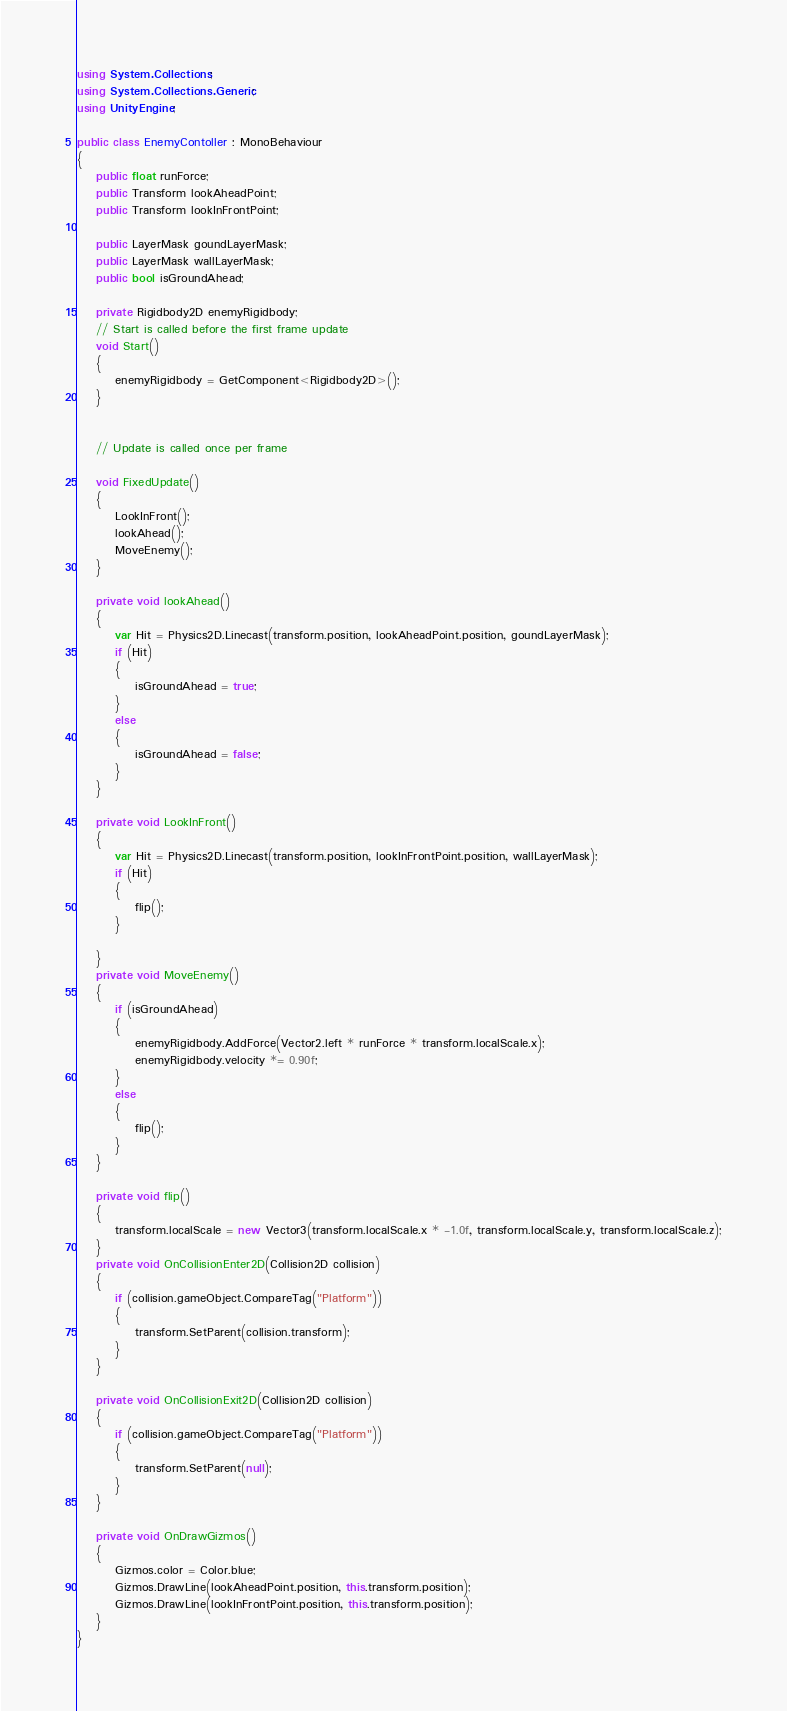Convert code to text. <code><loc_0><loc_0><loc_500><loc_500><_C#_>using System.Collections;
using System.Collections.Generic;
using UnityEngine;

public class EnemyContoller : MonoBehaviour
{
    public float runForce;
    public Transform lookAheadPoint;
    public Transform lookInFrontPoint;

    public LayerMask goundLayerMask;
    public LayerMask wallLayerMask;
    public bool isGroundAhead;

    private Rigidbody2D enemyRigidbody;
    // Start is called before the first frame update
    void Start()
    {
        enemyRigidbody = GetComponent<Rigidbody2D>();
    }

    
    // Update is called once per frame
    
    void FixedUpdate()
    {
        LookInFront();
        lookAhead();
        MoveEnemy();
    }

    private void lookAhead()
    {
        var Hit = Physics2D.Linecast(transform.position, lookAheadPoint.position, goundLayerMask);
        if (Hit)
        {
            isGroundAhead = true;
        }
        else
        {
            isGroundAhead = false;
        }
    }

    private void LookInFront()
    {
        var Hit = Physics2D.Linecast(transform.position, lookInFrontPoint.position, wallLayerMask);
        if (Hit)
        {
            flip();
        }
               
    }
    private void MoveEnemy()
    {
        if (isGroundAhead)
        {
            enemyRigidbody.AddForce(Vector2.left * runForce * transform.localScale.x);
            enemyRigidbody.velocity *= 0.90f;
        }
        else
        {
            flip();
        }
    }

    private void flip()
    {
        transform.localScale = new Vector3(transform.localScale.x * -1.0f, transform.localScale.y, transform.localScale.z);
    }
    private void OnCollisionEnter2D(Collision2D collision)
    {
        if (collision.gameObject.CompareTag("Platform"))
        {
            transform.SetParent(collision.transform);
        }
    }

    private void OnCollisionExit2D(Collision2D collision)
    {
        if (collision.gameObject.CompareTag("Platform"))
        {
            transform.SetParent(null);
        }
    }

    private void OnDrawGizmos()
    {
        Gizmos.color = Color.blue;
        Gizmos.DrawLine(lookAheadPoint.position, this.transform.position);
        Gizmos.DrawLine(lookInFrontPoint.position, this.transform.position);
    }
}
</code> 